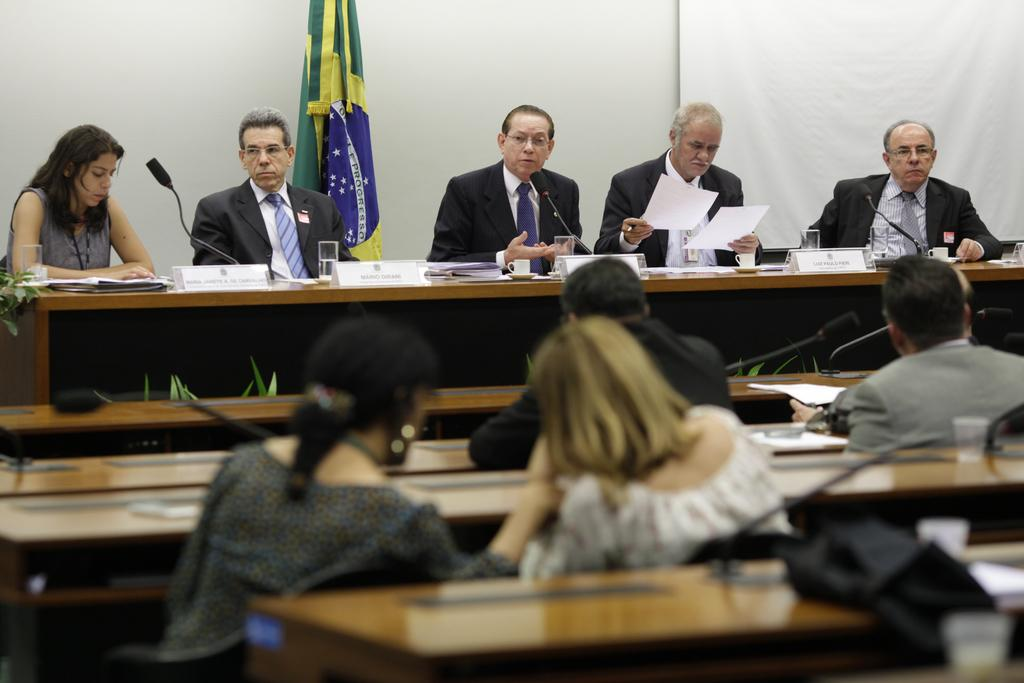How many people are in the image? There is a group of people in the image. What are the people doing in the image? The people are sitting on chairs. What objects can be seen on the tables in the image? There are microphones, papers, a board, and glass on the tables. What is visible in the background of the image? There is a wall and a flag in the background of the image. What type of polish is being applied to the board in the image? There is no polish being applied to the board in the image. How does the growth of the plants in the image affect the meeting? There are no plants present in the image, so their growth cannot affect the meeting. 